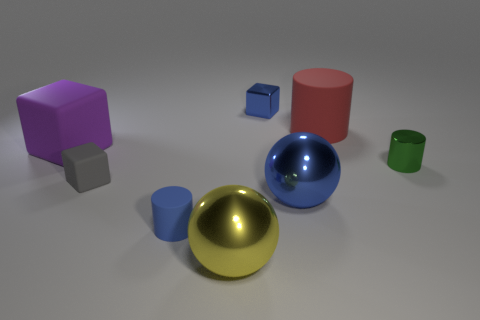If you had to guess, which object seems out of place in this collection and why? If one object had to be chosen as out of place, it might be the green cylinder due to its smaller size and less reflective surface compared to the other objects, which creates a less harmonious visual line when considering the arrangement based on size and luster. 